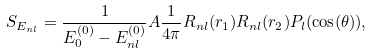Convert formula to latex. <formula><loc_0><loc_0><loc_500><loc_500>S _ { E _ { n l } } = \frac { 1 } { E _ { 0 } ^ { ( 0 ) } - E _ { n l } ^ { ( 0 ) } } A \frac { 1 } { 4 \pi } R _ { n l } ( r _ { 1 } ) R _ { n l } ( r _ { 2 } ) P _ { l } ( \cos ( \theta ) ) ,</formula> 